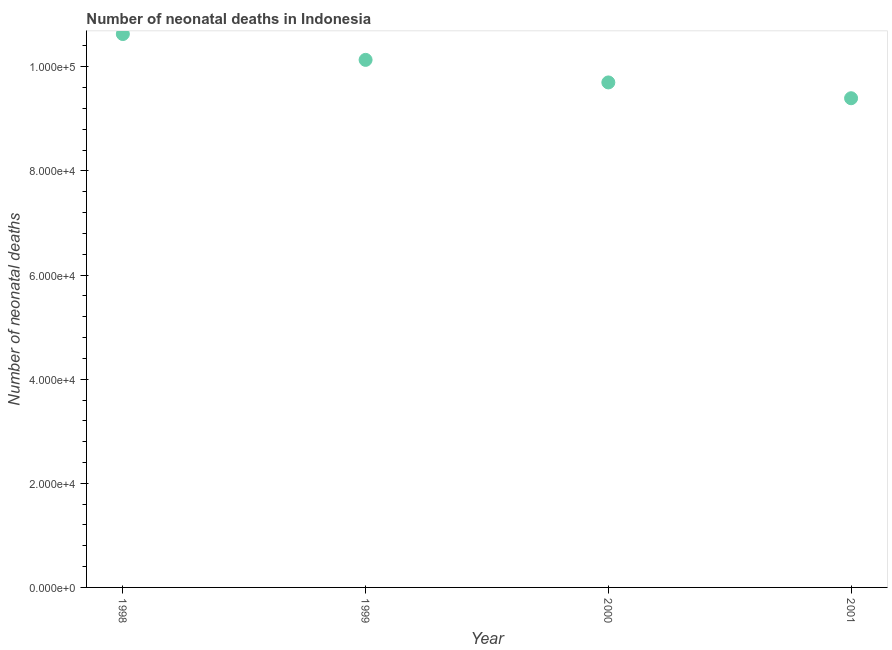What is the number of neonatal deaths in 2000?
Your answer should be compact. 9.70e+04. Across all years, what is the maximum number of neonatal deaths?
Your answer should be compact. 1.06e+05. Across all years, what is the minimum number of neonatal deaths?
Keep it short and to the point. 9.40e+04. In which year was the number of neonatal deaths minimum?
Offer a terse response. 2001. What is the sum of the number of neonatal deaths?
Keep it short and to the point. 3.99e+05. What is the difference between the number of neonatal deaths in 1998 and 2001?
Keep it short and to the point. 1.23e+04. What is the average number of neonatal deaths per year?
Ensure brevity in your answer.  9.97e+04. What is the median number of neonatal deaths?
Your answer should be compact. 9.92e+04. In how many years, is the number of neonatal deaths greater than 36000 ?
Give a very brief answer. 4. What is the ratio of the number of neonatal deaths in 1999 to that in 2000?
Make the answer very short. 1.04. Is the number of neonatal deaths in 1999 less than that in 2000?
Your response must be concise. No. What is the difference between the highest and the second highest number of neonatal deaths?
Your response must be concise. 4963. What is the difference between the highest and the lowest number of neonatal deaths?
Your answer should be compact. 1.23e+04. Does the number of neonatal deaths monotonically increase over the years?
Offer a terse response. No. How many dotlines are there?
Make the answer very short. 1. How many years are there in the graph?
Provide a short and direct response. 4. What is the difference between two consecutive major ticks on the Y-axis?
Make the answer very short. 2.00e+04. Are the values on the major ticks of Y-axis written in scientific E-notation?
Your answer should be very brief. Yes. Does the graph contain any zero values?
Give a very brief answer. No. What is the title of the graph?
Provide a succinct answer. Number of neonatal deaths in Indonesia. What is the label or title of the X-axis?
Your answer should be very brief. Year. What is the label or title of the Y-axis?
Keep it short and to the point. Number of neonatal deaths. What is the Number of neonatal deaths in 1998?
Provide a succinct answer. 1.06e+05. What is the Number of neonatal deaths in 1999?
Give a very brief answer. 1.01e+05. What is the Number of neonatal deaths in 2000?
Provide a short and direct response. 9.70e+04. What is the Number of neonatal deaths in 2001?
Your answer should be compact. 9.40e+04. What is the difference between the Number of neonatal deaths in 1998 and 1999?
Your answer should be compact. 4963. What is the difference between the Number of neonatal deaths in 1998 and 2000?
Offer a terse response. 9296. What is the difference between the Number of neonatal deaths in 1998 and 2001?
Offer a very short reply. 1.23e+04. What is the difference between the Number of neonatal deaths in 1999 and 2000?
Keep it short and to the point. 4333. What is the difference between the Number of neonatal deaths in 1999 and 2001?
Give a very brief answer. 7369. What is the difference between the Number of neonatal deaths in 2000 and 2001?
Offer a terse response. 3036. What is the ratio of the Number of neonatal deaths in 1998 to that in 1999?
Your response must be concise. 1.05. What is the ratio of the Number of neonatal deaths in 1998 to that in 2000?
Provide a succinct answer. 1.1. What is the ratio of the Number of neonatal deaths in 1998 to that in 2001?
Ensure brevity in your answer.  1.13. What is the ratio of the Number of neonatal deaths in 1999 to that in 2000?
Make the answer very short. 1.04. What is the ratio of the Number of neonatal deaths in 1999 to that in 2001?
Keep it short and to the point. 1.08. What is the ratio of the Number of neonatal deaths in 2000 to that in 2001?
Your answer should be compact. 1.03. 